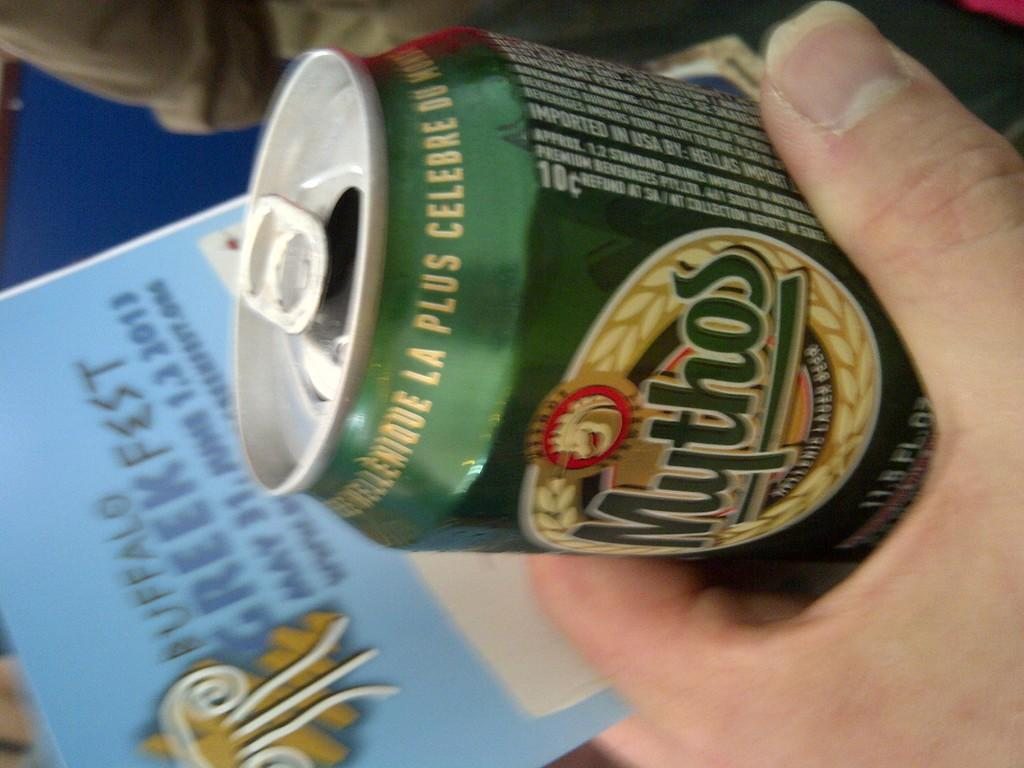Provide a one-sentence caption for the provided image. hand clucthes a Mythos Greek beer can just above a flyer for A Greek fest just below. 